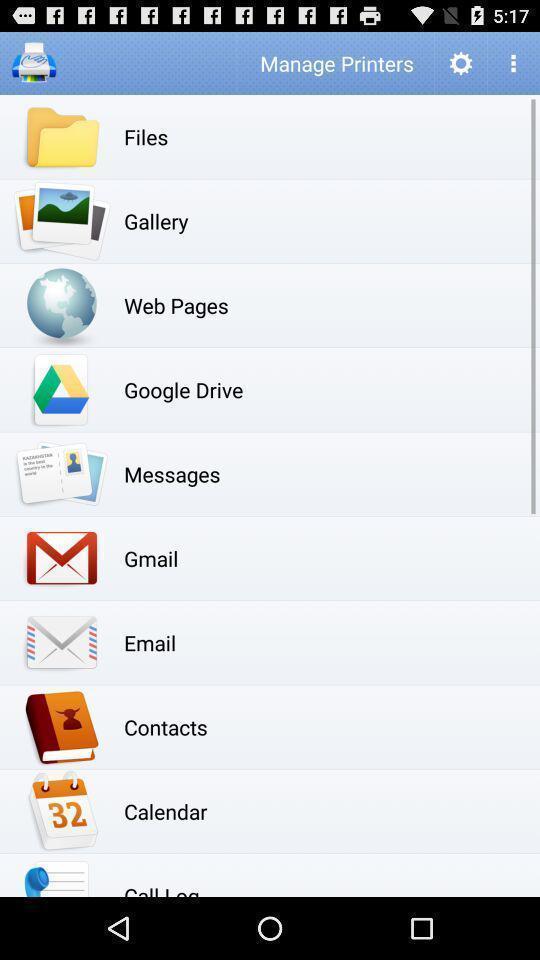Please provide a description for this image. Page displays list of applications. 